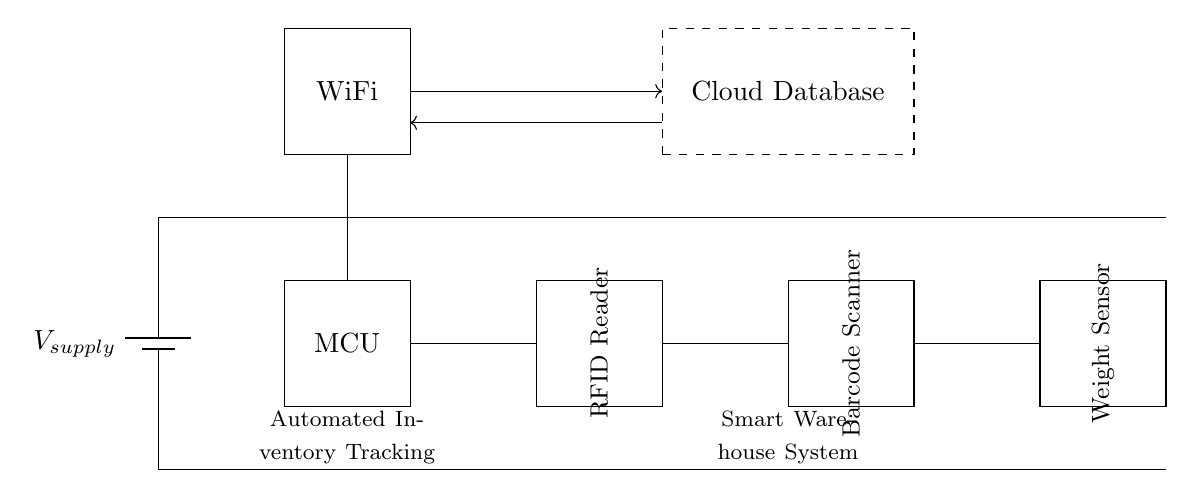What is the main power source in the circuit? The main power source is represented by a battery symbol, labeled as V_supply. It provides the necessary voltage to power the entire circuit.
Answer: V_supply How many sensors are present in the circuit? The circuit includes three sensor modules: an RFID Reader, a Barcode Scanner, and a Weight Sensor. These components are necessary for automated inventory tracking in a smart warehouse.
Answer: Three Which component is responsible for wireless communication? The component responsible for wireless communication is labeled as WiFi. It connects the circuit to external networks for data transmission to the Cloud Database.
Answer: WiFi What does the dashed rectangle represent? The dashed rectangle represents the Cloud Database. This indicates that it is a separate entity from the physical components in the circuit, where data is stored and processed.
Answer: Cloud Database How are the RFID Reader and Barcode Scanner connected? The RFID Reader and Barcode Scanner are connected through a direct line that extends horizontally across the circuit. This illustrates a data connection between these two components for inventory management.
Answer: Direct line What is the primary function of the microcontroller in this circuit? The microcontroller (MCU) is responsible for controlling and processing signals from the various sensors and facilitating communication with the WiFi module and Cloud Database.
Answer: Control and processing What type of system is illustrated by this circuit? The system illustrated in the circuit is an Automated Inventory Tracking System designed for Smart Warehouses. It integrates various components to efficiently manage stock levels and inventory data.
Answer: Automated Inventory Tracking System 